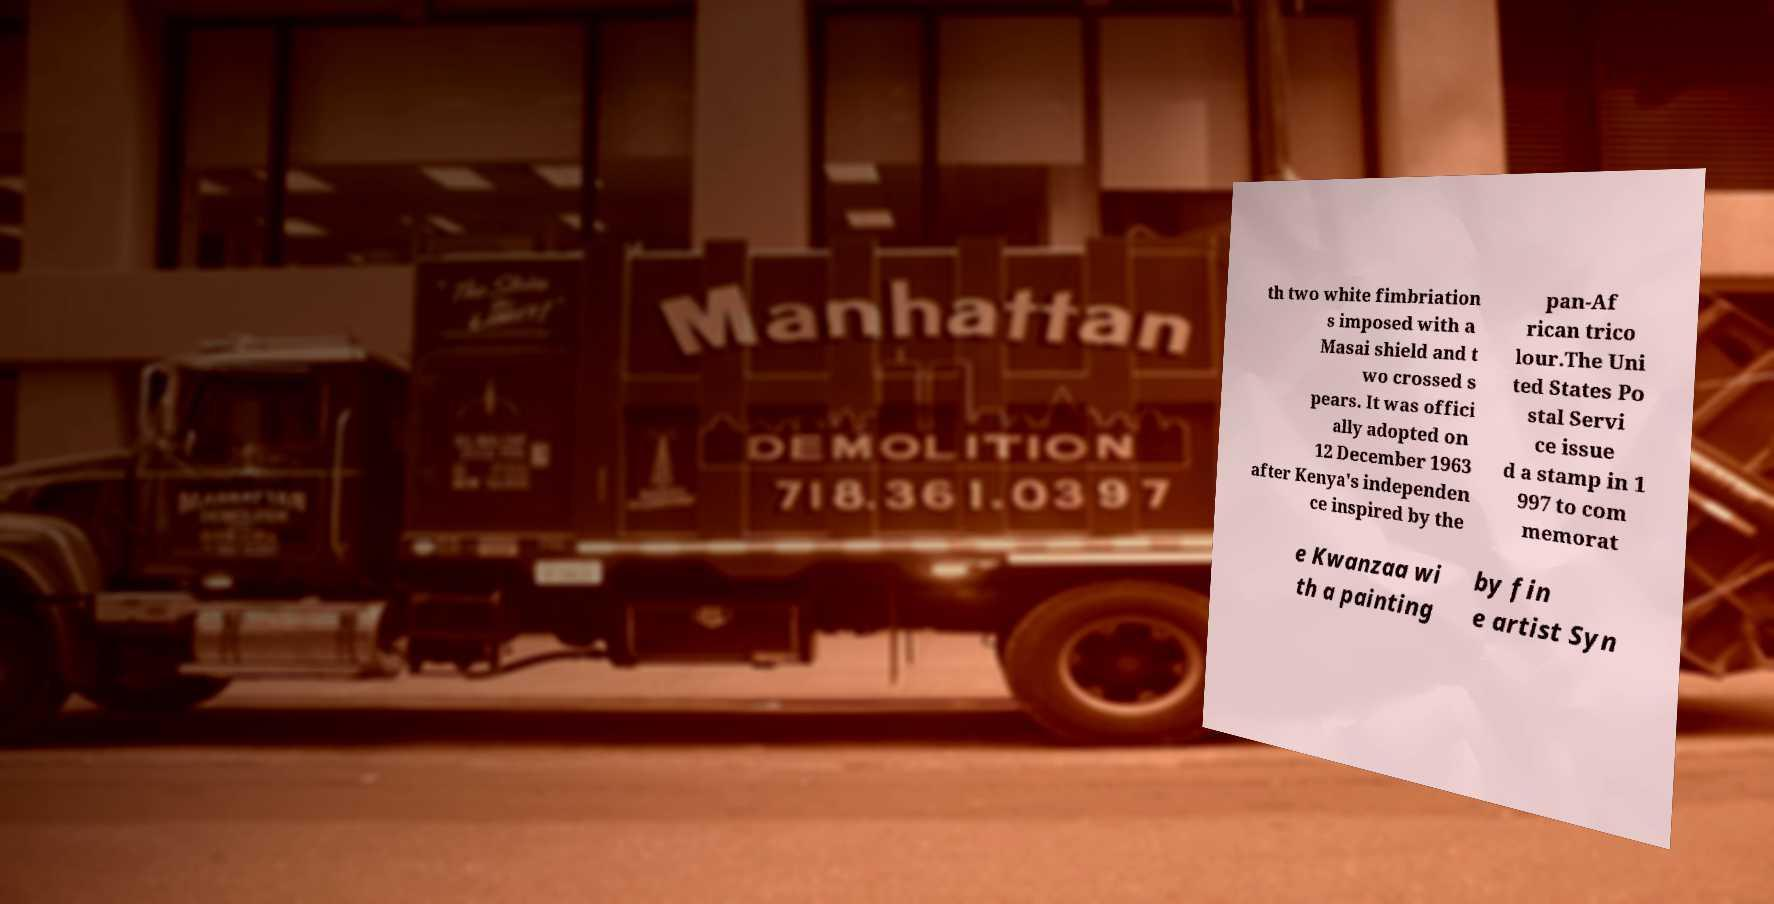Can you accurately transcribe the text from the provided image for me? th two white fimbriation s imposed with a Masai shield and t wo crossed s pears. It was offici ally adopted on 12 December 1963 after Kenya's independen ce inspired by the pan-Af rican trico lour.The Uni ted States Po stal Servi ce issue d a stamp in 1 997 to com memorat e Kwanzaa wi th a painting by fin e artist Syn 